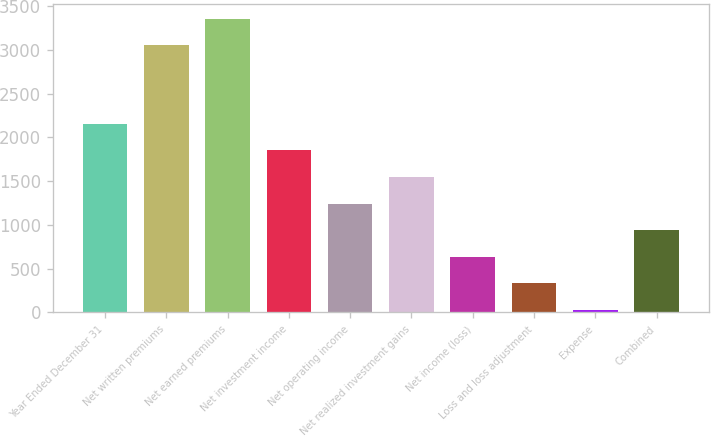<chart> <loc_0><loc_0><loc_500><loc_500><bar_chart><fcel>Year Ended December 31<fcel>Net written premiums<fcel>Net earned premiums<fcel>Net investment income<fcel>Net operating income<fcel>Net realized investment gains<fcel>Net income (loss)<fcel>Loss and loss adjustment<fcel>Expense<fcel>Combined<nl><fcel>2154.98<fcel>3054<fcel>3357.34<fcel>1851.64<fcel>1244.96<fcel>1548.3<fcel>638.28<fcel>334.94<fcel>31.6<fcel>941.62<nl></chart> 